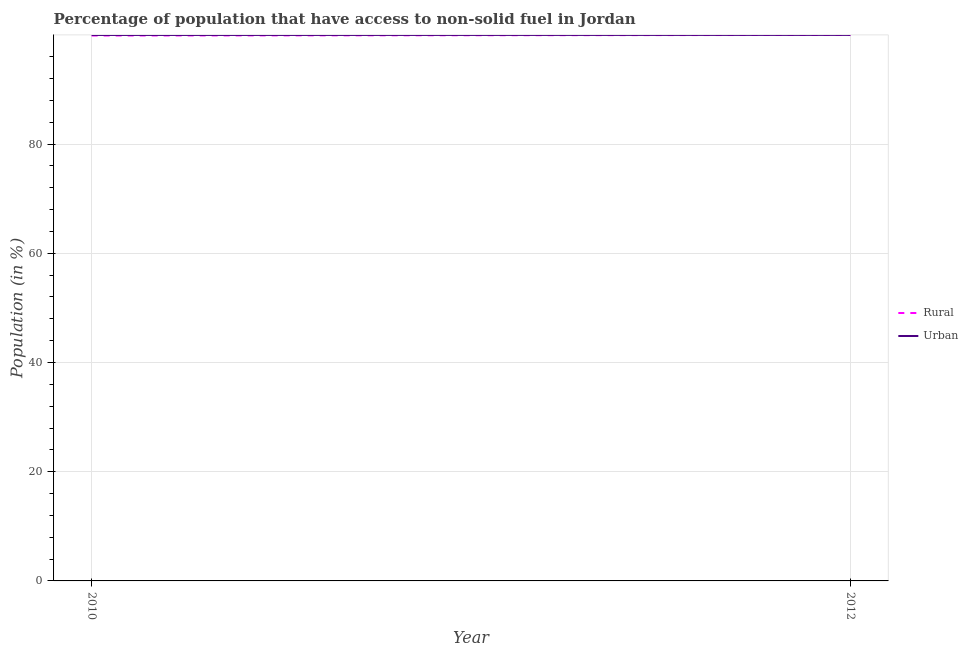Does the line corresponding to urban population intersect with the line corresponding to rural population?
Give a very brief answer. No. Is the number of lines equal to the number of legend labels?
Your answer should be compact. Yes. What is the urban population in 2012?
Provide a succinct answer. 99.99. Across all years, what is the maximum urban population?
Keep it short and to the point. 99.99. Across all years, what is the minimum urban population?
Your answer should be very brief. 99.98. What is the total urban population in the graph?
Make the answer very short. 199.97. What is the difference between the rural population in 2010 and that in 2012?
Make the answer very short. -0.11. What is the difference between the urban population in 2012 and the rural population in 2010?
Your answer should be compact. 0.11. What is the average rural population per year?
Your answer should be compact. 99.93. In the year 2012, what is the difference between the rural population and urban population?
Offer a very short reply. -0. What is the ratio of the rural population in 2010 to that in 2012?
Ensure brevity in your answer.  1. Is the urban population in 2010 less than that in 2012?
Offer a terse response. Yes. In how many years, is the urban population greater than the average urban population taken over all years?
Keep it short and to the point. 1. Does the urban population monotonically increase over the years?
Offer a very short reply. Yes. How many lines are there?
Make the answer very short. 2. How many years are there in the graph?
Provide a short and direct response. 2. What is the difference between two consecutive major ticks on the Y-axis?
Provide a short and direct response. 20. Does the graph contain grids?
Keep it short and to the point. Yes. How are the legend labels stacked?
Give a very brief answer. Vertical. What is the title of the graph?
Ensure brevity in your answer.  Percentage of population that have access to non-solid fuel in Jordan. What is the Population (in %) in Rural in 2010?
Your answer should be compact. 99.88. What is the Population (in %) of Urban in 2010?
Offer a very short reply. 99.98. What is the Population (in %) in Rural in 2012?
Offer a terse response. 99.99. What is the Population (in %) in Urban in 2012?
Your answer should be very brief. 99.99. Across all years, what is the maximum Population (in %) of Rural?
Provide a succinct answer. 99.99. Across all years, what is the maximum Population (in %) of Urban?
Your response must be concise. 99.99. Across all years, what is the minimum Population (in %) in Rural?
Your answer should be very brief. 99.88. Across all years, what is the minimum Population (in %) of Urban?
Keep it short and to the point. 99.98. What is the total Population (in %) of Rural in the graph?
Provide a short and direct response. 199.87. What is the total Population (in %) in Urban in the graph?
Offer a very short reply. 199.97. What is the difference between the Population (in %) of Rural in 2010 and that in 2012?
Offer a very short reply. -0.11. What is the difference between the Population (in %) of Urban in 2010 and that in 2012?
Make the answer very short. -0.01. What is the difference between the Population (in %) of Rural in 2010 and the Population (in %) of Urban in 2012?
Offer a terse response. -0.11. What is the average Population (in %) of Rural per year?
Your response must be concise. 99.93. What is the average Population (in %) in Urban per year?
Make the answer very short. 99.98. In the year 2010, what is the difference between the Population (in %) of Rural and Population (in %) of Urban?
Make the answer very short. -0.1. In the year 2012, what is the difference between the Population (in %) of Rural and Population (in %) of Urban?
Ensure brevity in your answer.  -0. What is the ratio of the Population (in %) in Rural in 2010 to that in 2012?
Provide a short and direct response. 1. What is the ratio of the Population (in %) in Urban in 2010 to that in 2012?
Your answer should be compact. 1. What is the difference between the highest and the second highest Population (in %) in Rural?
Provide a short and direct response. 0.11. What is the difference between the highest and the second highest Population (in %) of Urban?
Give a very brief answer. 0.01. What is the difference between the highest and the lowest Population (in %) of Rural?
Make the answer very short. 0.11. What is the difference between the highest and the lowest Population (in %) of Urban?
Your response must be concise. 0.01. 